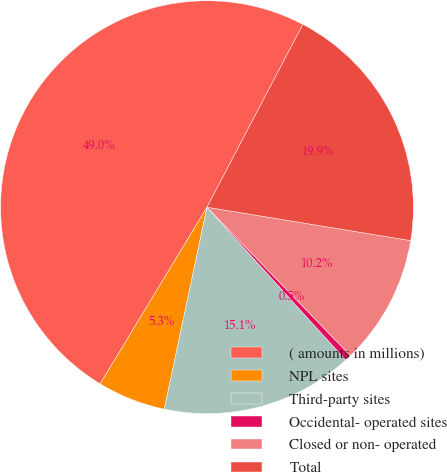Convert chart. <chart><loc_0><loc_0><loc_500><loc_500><pie_chart><fcel>( amounts in millions)<fcel>NPL sites<fcel>Third-party sites<fcel>Occidental- operated sites<fcel>Closed or non- operated<fcel>Total<nl><fcel>49.03%<fcel>5.34%<fcel>15.05%<fcel>0.49%<fcel>10.19%<fcel>19.9%<nl></chart> 